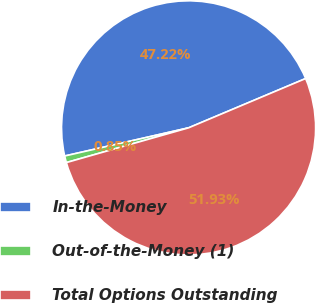Convert chart to OTSL. <chart><loc_0><loc_0><loc_500><loc_500><pie_chart><fcel>In-the-Money<fcel>Out-of-the-Money (1)<fcel>Total Options Outstanding<nl><fcel>47.22%<fcel>0.85%<fcel>51.94%<nl></chart> 